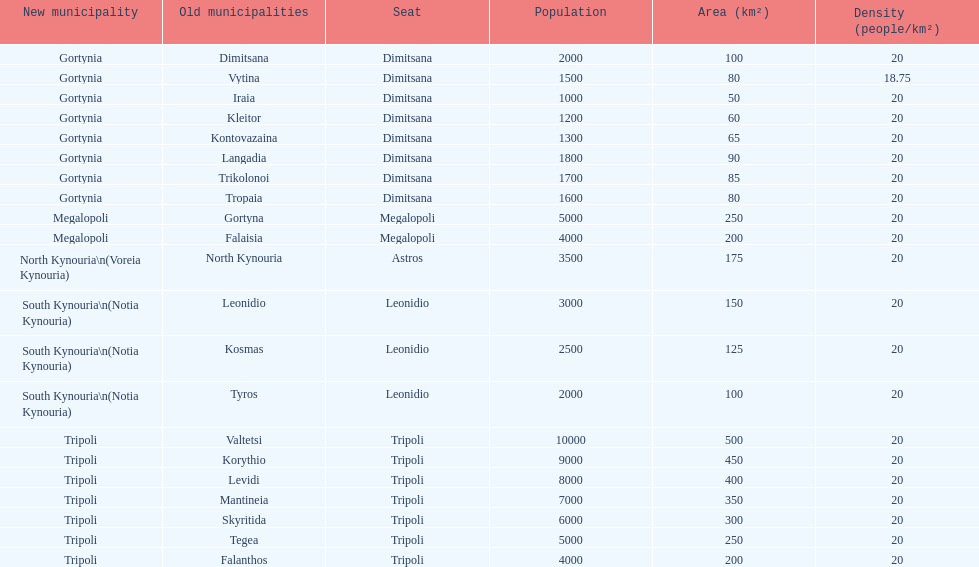When arcadia was reformed in 2011, how many municipalities were created? 5. 